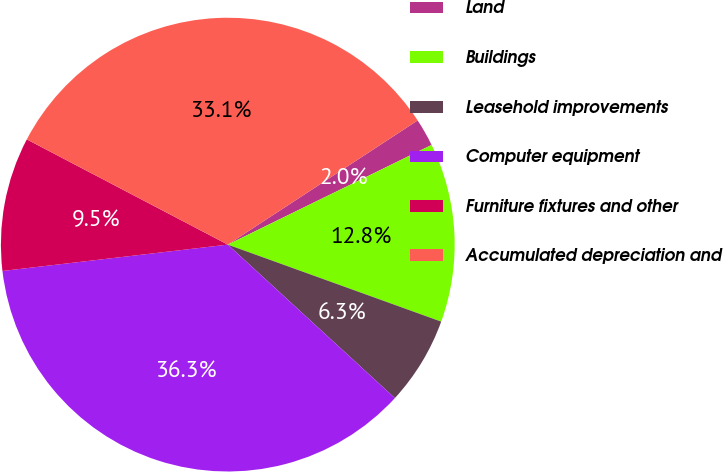<chart> <loc_0><loc_0><loc_500><loc_500><pie_chart><fcel>Land<fcel>Buildings<fcel>Leasehold improvements<fcel>Computer equipment<fcel>Furniture fixtures and other<fcel>Accumulated depreciation and<nl><fcel>1.98%<fcel>12.75%<fcel>6.31%<fcel>36.32%<fcel>9.53%<fcel>33.1%<nl></chart> 